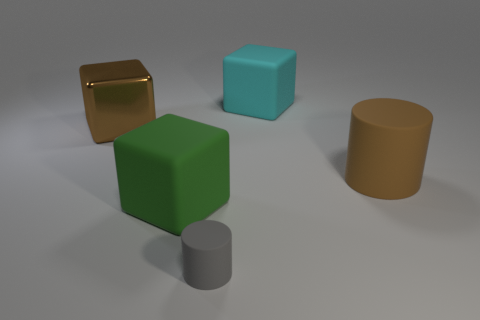Add 2 cyan objects. How many objects exist? 7 Subtract all cylinders. How many objects are left? 3 Subtract 0 red cylinders. How many objects are left? 5 Subtract all yellow rubber things. Subtract all gray rubber things. How many objects are left? 4 Add 4 big things. How many big things are left? 8 Add 1 cyan cubes. How many cyan cubes exist? 2 